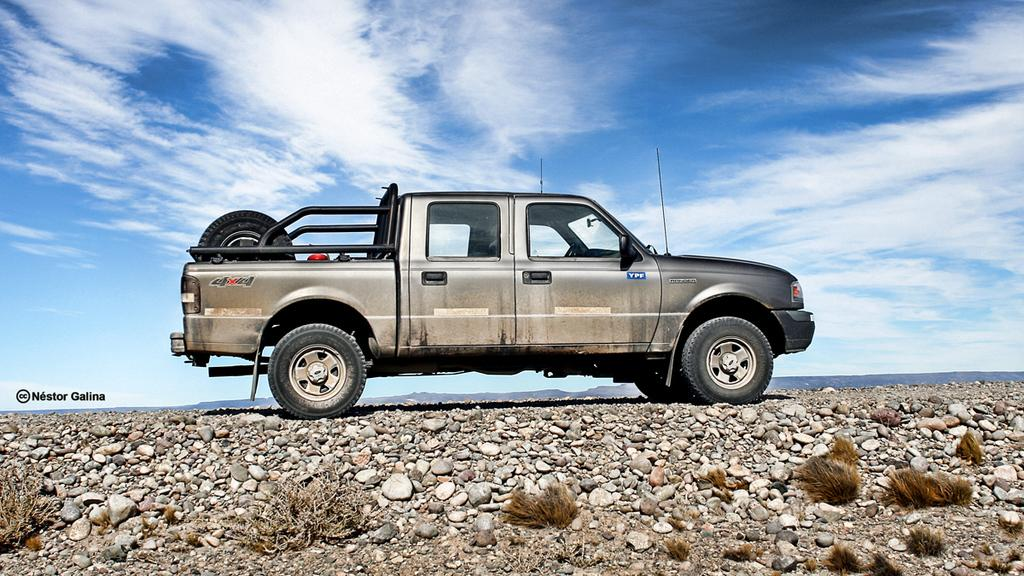What is the main subject of the image? The main subject of the image is a car. What can be seen at the bottom of the image? Grass and stones are visible at the bottom of the image. What is visible in the sky in the image? Clouds are visible at the top of the image. How many wheels does the car have? The car has wheels. What shape is the nose of the person sitting in the car in the image? There is no person sitting in the car in the image, and therefore no nose is visible. 